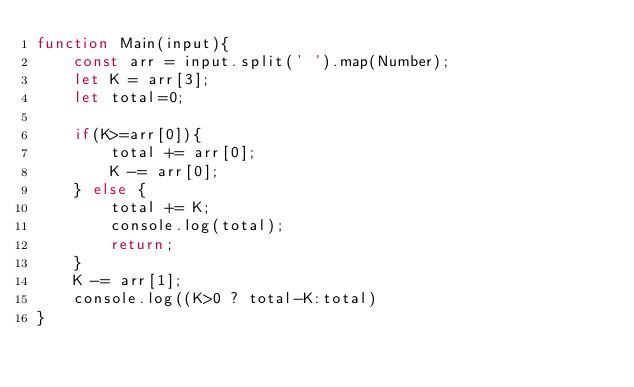Convert code to text. <code><loc_0><loc_0><loc_500><loc_500><_JavaScript_>function Main(input){
    const arr = input.split(' ').map(Number);
    let K = arr[3];
    let total=0;
 
    if(K>=arr[0]){
        total += arr[0];
        K -= arr[0];
    } else {
        total += K;
        console.log(total);
        return;
    }
    K -= arr[1];    
    console.log((K>0 ? total-K:total)
}</code> 